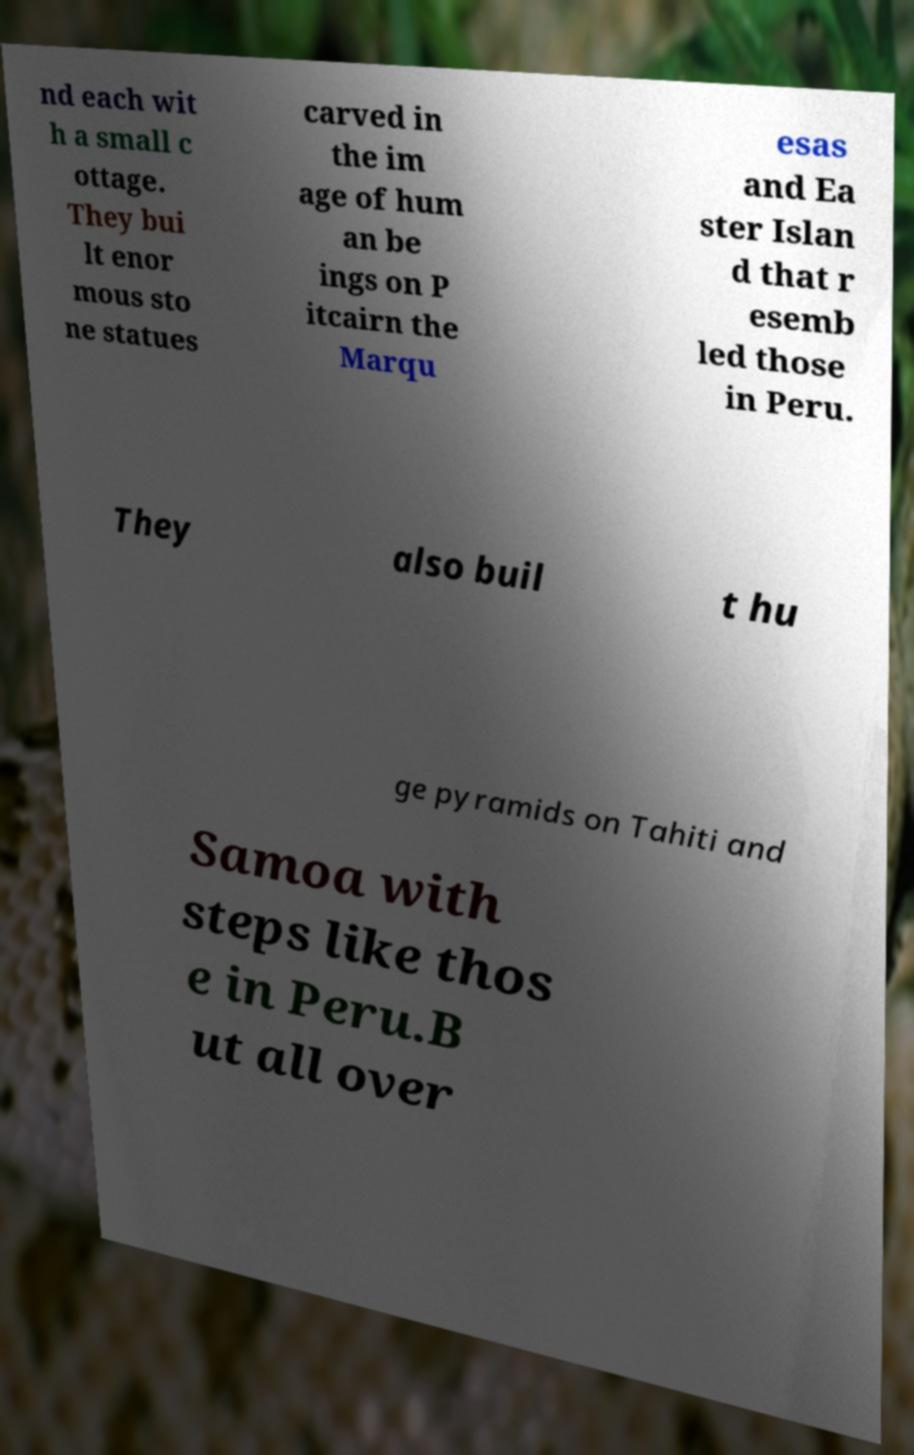I need the written content from this picture converted into text. Can you do that? nd each wit h a small c ottage. They bui lt enor mous sto ne statues carved in the im age of hum an be ings on P itcairn the Marqu esas and Ea ster Islan d that r esemb led those in Peru. They also buil t hu ge pyramids on Tahiti and Samoa with steps like thos e in Peru.B ut all over 